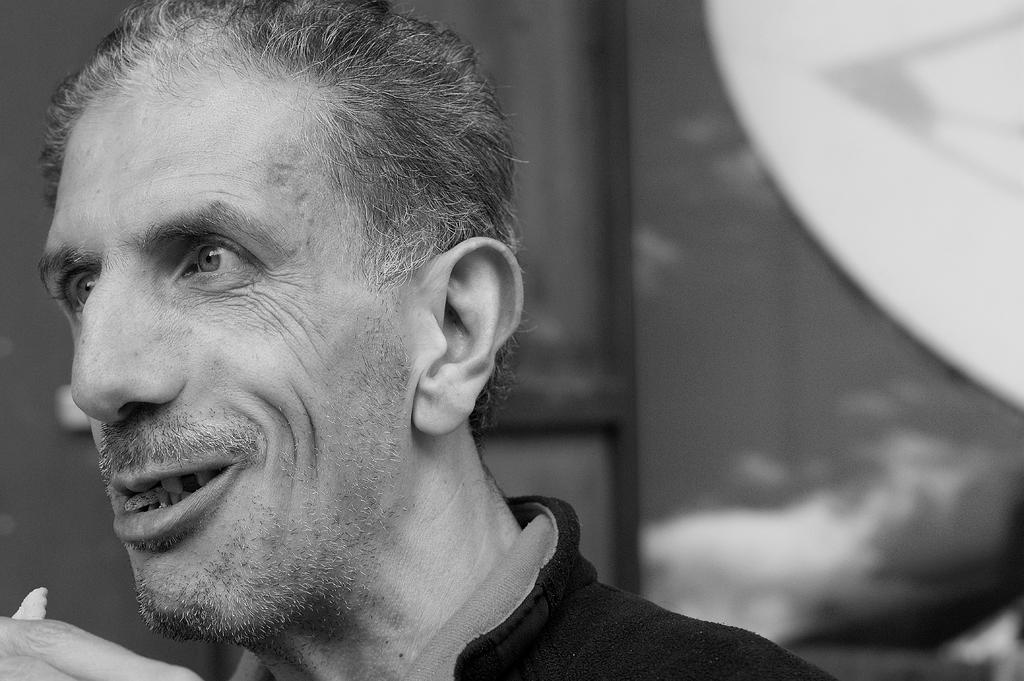What is the color scheme of the image? The image is black and white. Can you describe the main subject of the image? There is a man in the image. What can be observed about the background in the image? The background behind the man is blurred. What type of songs can be heard in the background of the image? There are no songs present in the image, as it is a black and white photograph of a man with a blurred background. 